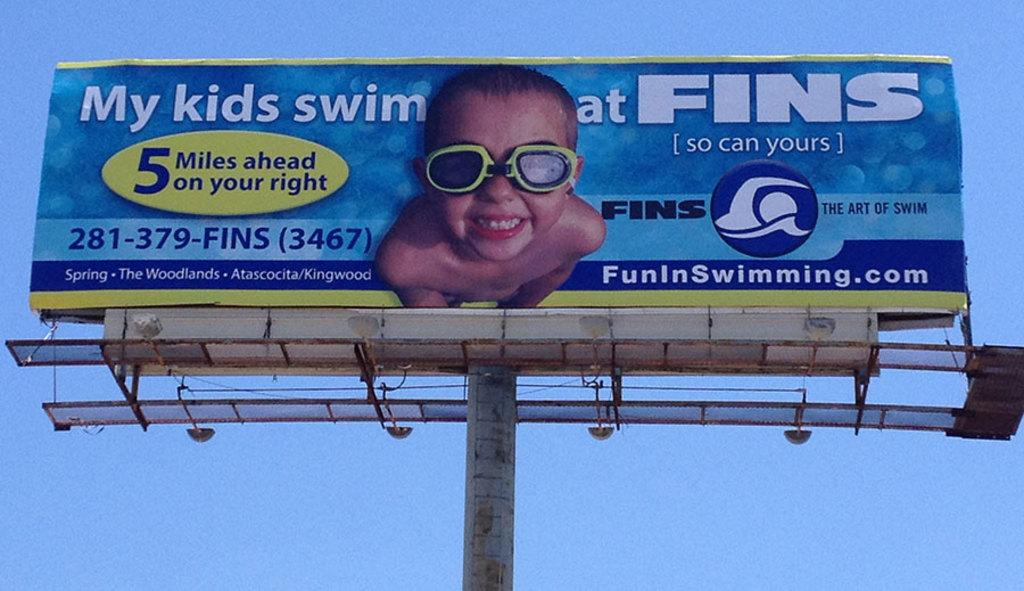<image>
Offer a succinct explanation of the picture presented. A billboard with a child on it advertising for FINS swimming. 